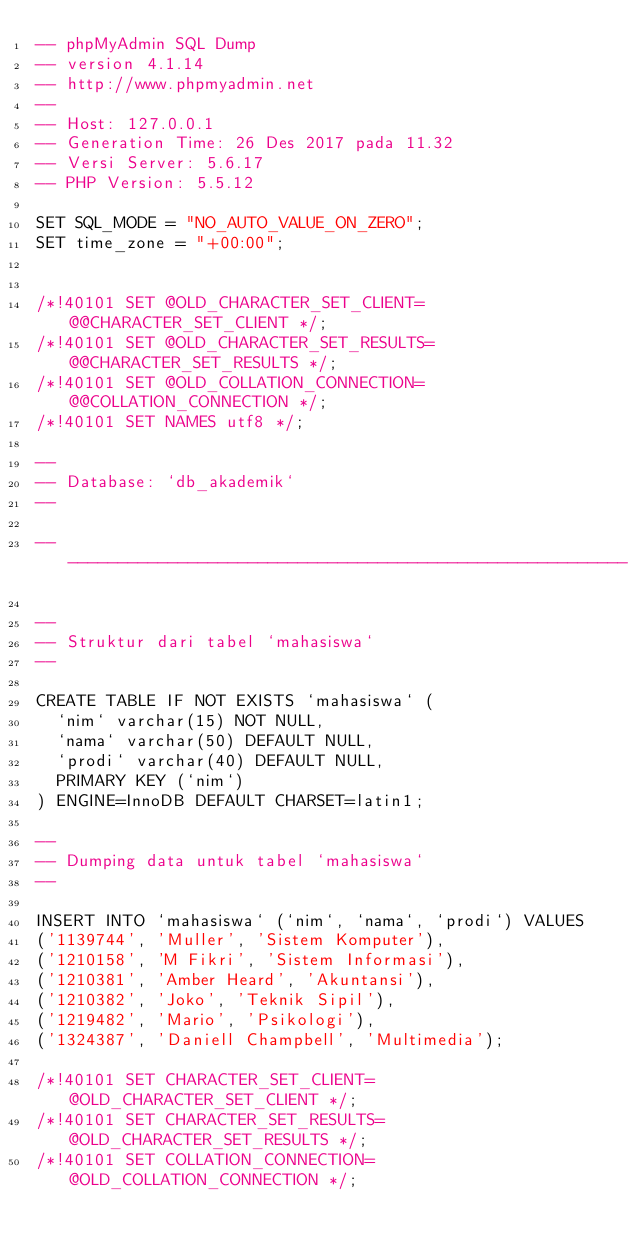Convert code to text. <code><loc_0><loc_0><loc_500><loc_500><_SQL_>-- phpMyAdmin SQL Dump
-- version 4.1.14
-- http://www.phpmyadmin.net
--
-- Host: 127.0.0.1
-- Generation Time: 26 Des 2017 pada 11.32
-- Versi Server: 5.6.17
-- PHP Version: 5.5.12

SET SQL_MODE = "NO_AUTO_VALUE_ON_ZERO";
SET time_zone = "+00:00";


/*!40101 SET @OLD_CHARACTER_SET_CLIENT=@@CHARACTER_SET_CLIENT */;
/*!40101 SET @OLD_CHARACTER_SET_RESULTS=@@CHARACTER_SET_RESULTS */;
/*!40101 SET @OLD_COLLATION_CONNECTION=@@COLLATION_CONNECTION */;
/*!40101 SET NAMES utf8 */;

--
-- Database: `db_akademik`
--

-- --------------------------------------------------------

--
-- Struktur dari tabel `mahasiswa`
--

CREATE TABLE IF NOT EXISTS `mahasiswa` (
  `nim` varchar(15) NOT NULL,
  `nama` varchar(50) DEFAULT NULL,
  `prodi` varchar(40) DEFAULT NULL,
  PRIMARY KEY (`nim`)
) ENGINE=InnoDB DEFAULT CHARSET=latin1;

--
-- Dumping data untuk tabel `mahasiswa`
--

INSERT INTO `mahasiswa` (`nim`, `nama`, `prodi`) VALUES
('1139744', 'Muller', 'Sistem Komputer'),
('1210158', 'M Fikri', 'Sistem Informasi'),
('1210381', 'Amber Heard', 'Akuntansi'),
('1210382', 'Joko', 'Teknik Sipil'),
('1219482', 'Mario', 'Psikologi'),
('1324387', 'Daniell Champbell', 'Multimedia');

/*!40101 SET CHARACTER_SET_CLIENT=@OLD_CHARACTER_SET_CLIENT */;
/*!40101 SET CHARACTER_SET_RESULTS=@OLD_CHARACTER_SET_RESULTS */;
/*!40101 SET COLLATION_CONNECTION=@OLD_COLLATION_CONNECTION */;
</code> 